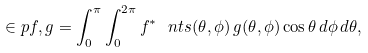<formula> <loc_0><loc_0><loc_500><loc_500>\in p { f , g } = \int _ { 0 } ^ { \pi } \int _ { 0 } ^ { 2 \pi } { f ^ { \ast } \ n t s ( \theta , \phi ) } \, g ( \theta , \phi ) \cos \theta \, d \phi \, d \theta ,</formula> 